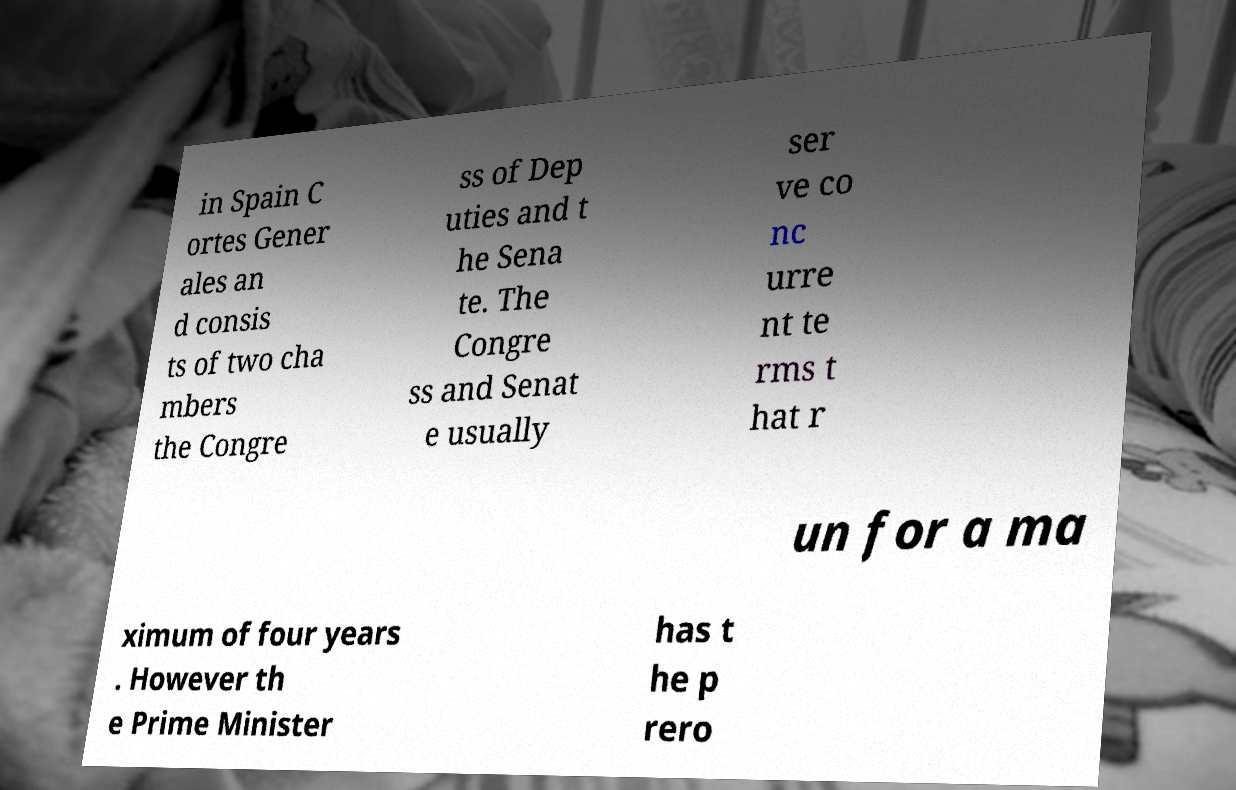What messages or text are displayed in this image? I need them in a readable, typed format. in Spain C ortes Gener ales an d consis ts of two cha mbers the Congre ss of Dep uties and t he Sena te. The Congre ss and Senat e usually ser ve co nc urre nt te rms t hat r un for a ma ximum of four years . However th e Prime Minister has t he p rero 